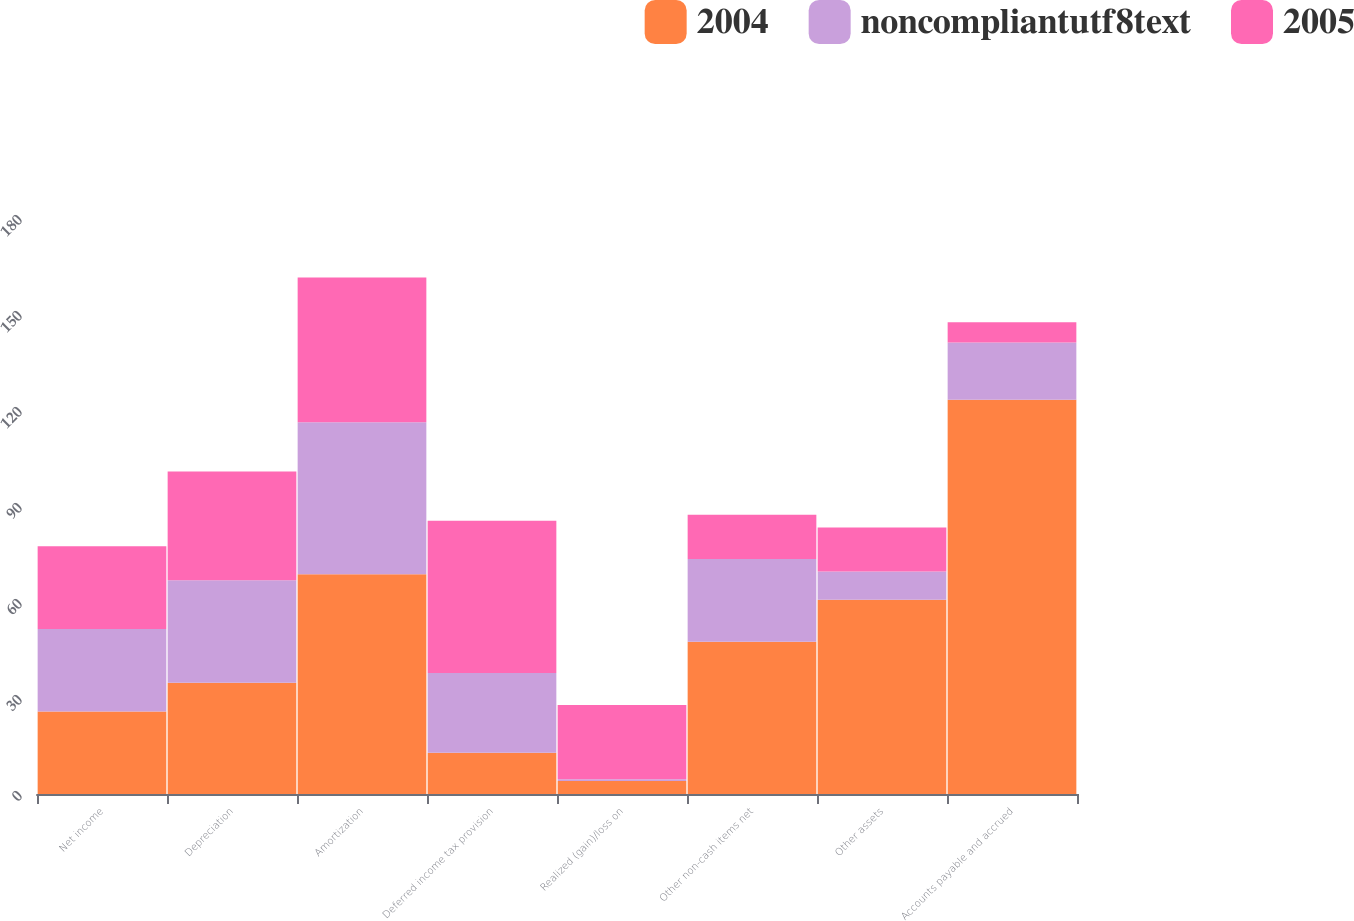<chart> <loc_0><loc_0><loc_500><loc_500><stacked_bar_chart><ecel><fcel>Net income<fcel>Depreciation<fcel>Amortization<fcel>Deferred income tax provision<fcel>Realized (gain)/loss on<fcel>Other non-cash items net<fcel>Other assets<fcel>Accounts payable and accrued<nl><fcel>2004<fcel>25.8<fcel>34.8<fcel>68.7<fcel>12.9<fcel>4.1<fcel>47.6<fcel>60.7<fcel>123.2<nl><fcel>noncompliantutf8text<fcel>25.8<fcel>32<fcel>47.5<fcel>24.9<fcel>0.5<fcel>25.8<fcel>8.8<fcel>17.9<nl><fcel>2005<fcel>25.8<fcel>34<fcel>45.2<fcel>47.6<fcel>23.2<fcel>13.9<fcel>13.8<fcel>6.3<nl></chart> 